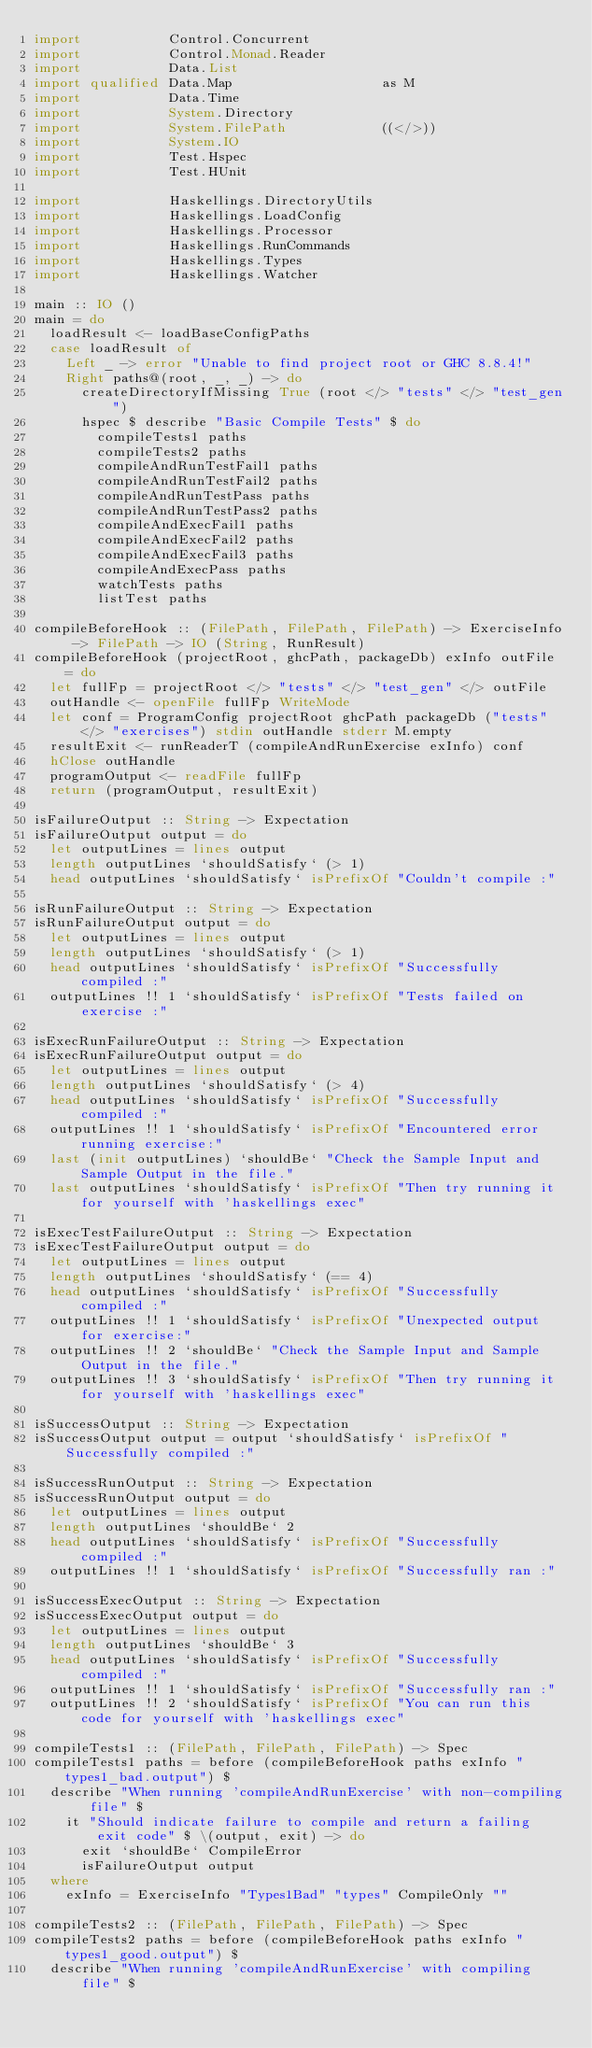<code> <loc_0><loc_0><loc_500><loc_500><_Haskell_>import           Control.Concurrent
import           Control.Monad.Reader
import           Data.List
import qualified Data.Map                   as M
import           Data.Time
import           System.Directory
import           System.FilePath            ((</>))
import           System.IO
import           Test.Hspec
import           Test.HUnit

import           Haskellings.DirectoryUtils
import           Haskellings.LoadConfig
import           Haskellings.Processor
import           Haskellings.RunCommands
import           Haskellings.Types
import           Haskellings.Watcher

main :: IO ()
main = do
  loadResult <- loadBaseConfigPaths
  case loadResult of
    Left _ -> error "Unable to find project root or GHC 8.8.4!"
    Right paths@(root, _, _) -> do
      createDirectoryIfMissing True (root </> "tests" </> "test_gen")
      hspec $ describe "Basic Compile Tests" $ do
        compileTests1 paths
        compileTests2 paths
        compileAndRunTestFail1 paths
        compileAndRunTestFail2 paths
        compileAndRunTestPass paths
        compileAndRunTestPass2 paths
        compileAndExecFail1 paths
        compileAndExecFail2 paths
        compileAndExecFail3 paths
        compileAndExecPass paths
        watchTests paths
        listTest paths

compileBeforeHook :: (FilePath, FilePath, FilePath) -> ExerciseInfo -> FilePath -> IO (String, RunResult)
compileBeforeHook (projectRoot, ghcPath, packageDb) exInfo outFile = do
  let fullFp = projectRoot </> "tests" </> "test_gen" </> outFile
  outHandle <- openFile fullFp WriteMode
  let conf = ProgramConfig projectRoot ghcPath packageDb ("tests" </> "exercises") stdin outHandle stderr M.empty
  resultExit <- runReaderT (compileAndRunExercise exInfo) conf
  hClose outHandle
  programOutput <- readFile fullFp
  return (programOutput, resultExit)

isFailureOutput :: String -> Expectation
isFailureOutput output = do
  let outputLines = lines output
  length outputLines `shouldSatisfy` (> 1)
  head outputLines `shouldSatisfy` isPrefixOf "Couldn't compile :"

isRunFailureOutput :: String -> Expectation
isRunFailureOutput output = do
  let outputLines = lines output
  length outputLines `shouldSatisfy` (> 1)
  head outputLines `shouldSatisfy` isPrefixOf "Successfully compiled :"
  outputLines !! 1 `shouldSatisfy` isPrefixOf "Tests failed on exercise :"

isExecRunFailureOutput :: String -> Expectation
isExecRunFailureOutput output = do
  let outputLines = lines output
  length outputLines `shouldSatisfy` (> 4)
  head outputLines `shouldSatisfy` isPrefixOf "Successfully compiled :"
  outputLines !! 1 `shouldSatisfy` isPrefixOf "Encountered error running exercise:"
  last (init outputLines) `shouldBe` "Check the Sample Input and Sample Output in the file."
  last outputLines `shouldSatisfy` isPrefixOf "Then try running it for yourself with 'haskellings exec"

isExecTestFailureOutput :: String -> Expectation
isExecTestFailureOutput output = do
  let outputLines = lines output
  length outputLines `shouldSatisfy` (== 4)
  head outputLines `shouldSatisfy` isPrefixOf "Successfully compiled :"
  outputLines !! 1 `shouldSatisfy` isPrefixOf "Unexpected output for exercise:"
  outputLines !! 2 `shouldBe` "Check the Sample Input and Sample Output in the file."
  outputLines !! 3 `shouldSatisfy` isPrefixOf "Then try running it for yourself with 'haskellings exec"

isSuccessOutput :: String -> Expectation
isSuccessOutput output = output `shouldSatisfy` isPrefixOf "Successfully compiled :"

isSuccessRunOutput :: String -> Expectation
isSuccessRunOutput output = do
  let outputLines = lines output
  length outputLines `shouldBe` 2
  head outputLines `shouldSatisfy` isPrefixOf "Successfully compiled :"
  outputLines !! 1 `shouldSatisfy` isPrefixOf "Successfully ran :"

isSuccessExecOutput :: String -> Expectation
isSuccessExecOutput output = do
  let outputLines = lines output
  length outputLines `shouldBe` 3
  head outputLines `shouldSatisfy` isPrefixOf "Successfully compiled :"
  outputLines !! 1 `shouldSatisfy` isPrefixOf "Successfully ran :"
  outputLines !! 2 `shouldSatisfy` isPrefixOf "You can run this code for yourself with 'haskellings exec"

compileTests1 :: (FilePath, FilePath, FilePath) -> Spec
compileTests1 paths = before (compileBeforeHook paths exInfo "types1_bad.output") $
  describe "When running 'compileAndRunExercise' with non-compiling file" $
    it "Should indicate failure to compile and return a failing exit code" $ \(output, exit) -> do
      exit `shouldBe` CompileError
      isFailureOutput output
  where
    exInfo = ExerciseInfo "Types1Bad" "types" CompileOnly ""

compileTests2 :: (FilePath, FilePath, FilePath) -> Spec
compileTests2 paths = before (compileBeforeHook paths exInfo "types1_good.output") $
  describe "When running 'compileAndRunExercise' with compiling file" $</code> 